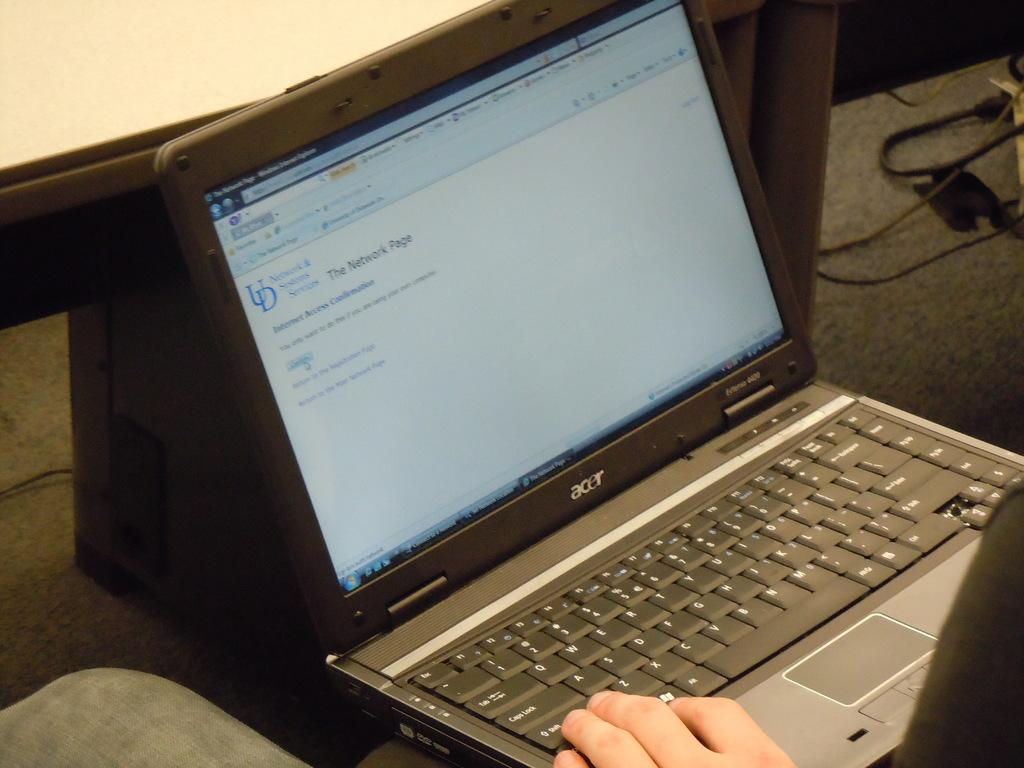<image>
Render a clear and concise summary of the photo. An acer brand laptop is being used in a meeting or classroom setting. 